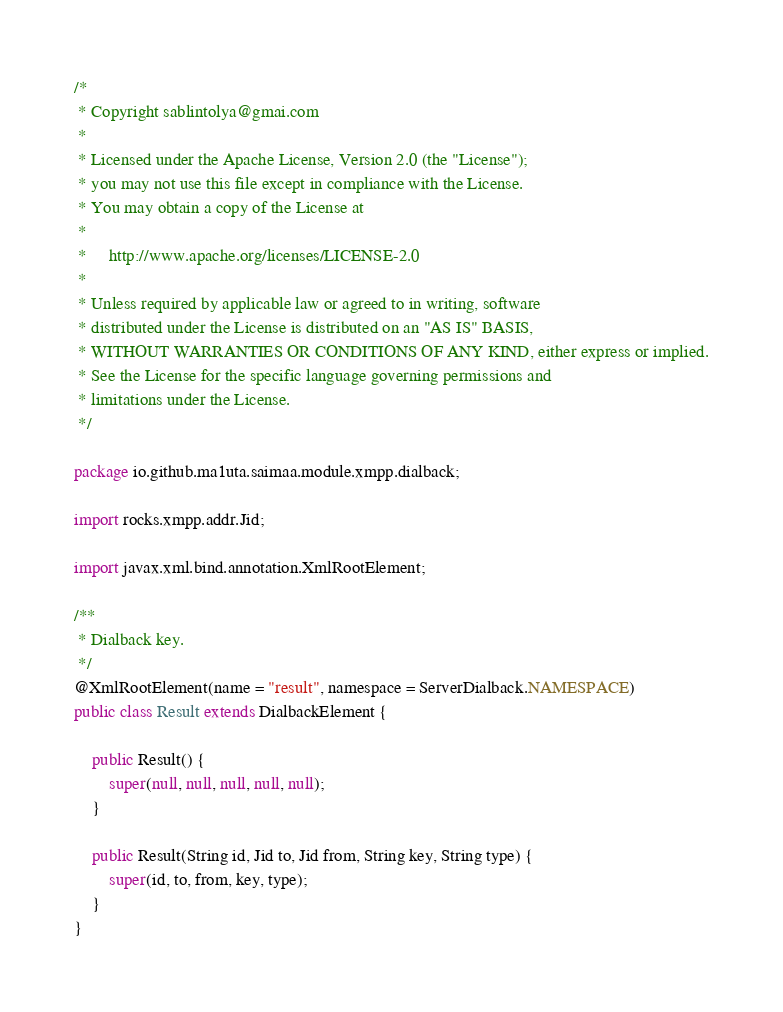<code> <loc_0><loc_0><loc_500><loc_500><_Java_>/*
 * Copyright sablintolya@gmai.com
 *
 * Licensed under the Apache License, Version 2.0 (the "License");
 * you may not use this file except in compliance with the License.
 * You may obtain a copy of the License at
 *
 *     http://www.apache.org/licenses/LICENSE-2.0
 *
 * Unless required by applicable law or agreed to in writing, software
 * distributed under the License is distributed on an "AS IS" BASIS,
 * WITHOUT WARRANTIES OR CONDITIONS OF ANY KIND, either express or implied.
 * See the License for the specific language governing permissions and
 * limitations under the License.
 */

package io.github.ma1uta.saimaa.module.xmpp.dialback;

import rocks.xmpp.addr.Jid;

import javax.xml.bind.annotation.XmlRootElement;

/**
 * Dialback key.
 */
@XmlRootElement(name = "result", namespace = ServerDialback.NAMESPACE)
public class Result extends DialbackElement {

    public Result() {
        super(null, null, null, null, null);
    }

    public Result(String id, Jid to, Jid from, String key, String type) {
        super(id, to, from, key, type);
    }
}

</code> 